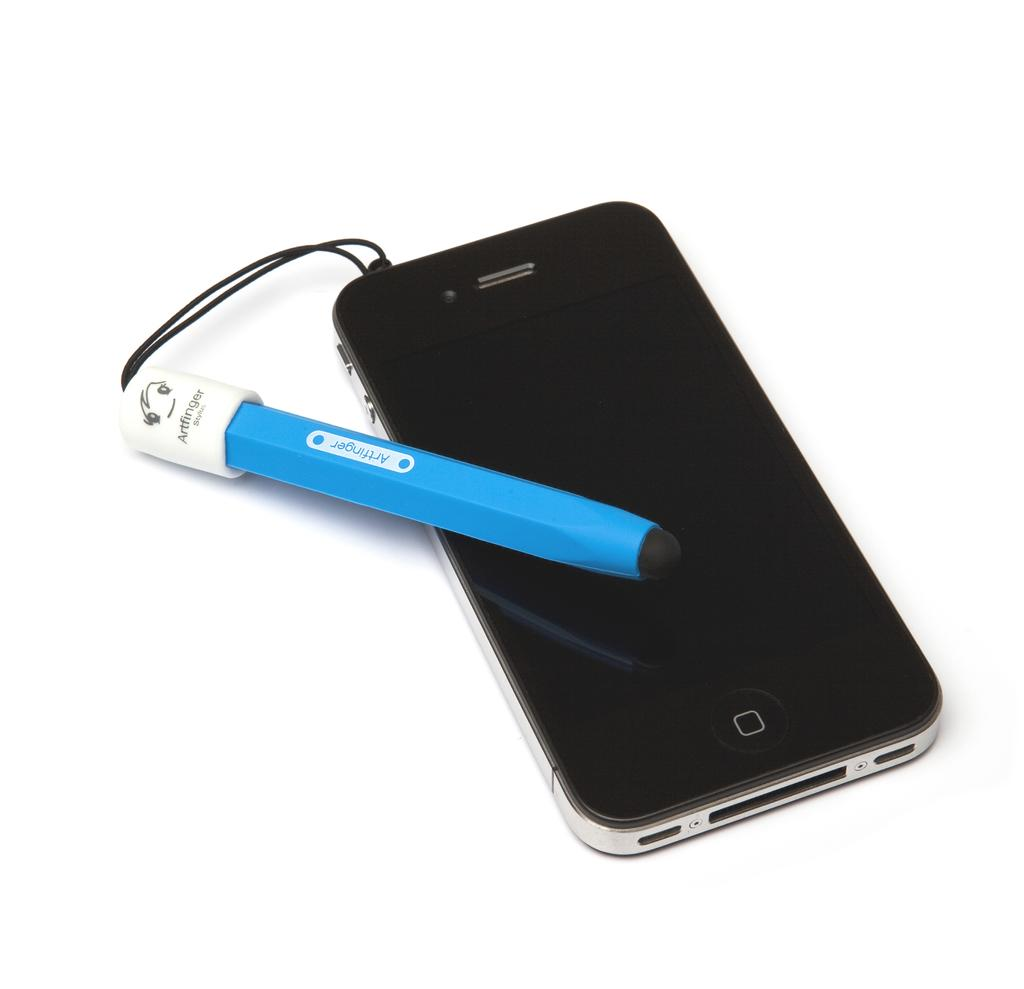<image>
Offer a succinct explanation of the picture presented. the name Artfinger is on a blue and white item next to a phone 